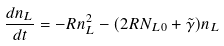<formula> <loc_0><loc_0><loc_500><loc_500>\frac { d n _ { L } } { d t } = - R n _ { L } ^ { 2 } - ( 2 R N _ { L 0 } + \tilde { \gamma } ) n _ { L }</formula> 